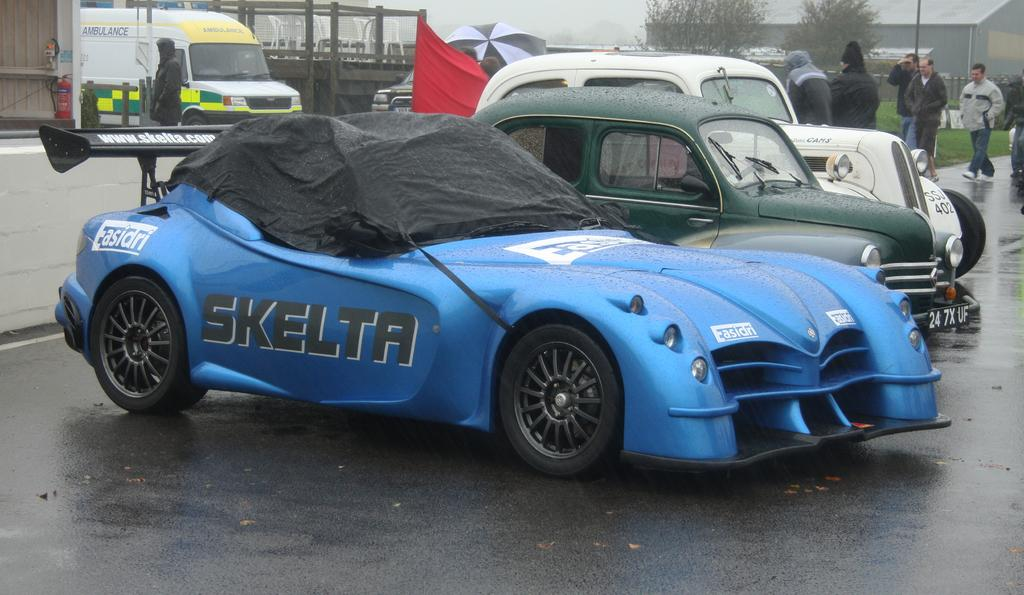What is happening on the road in the image? There are cars on a road in the image. What are the people in the image doing? People are walking in the image. What can be seen in the background of the image? There is a building, trees, and houses in the background of the image. What type of coat is the hill wearing in the image? There is no hill or coat present in the image. What kind of insurance policy is being discussed by the people walking in the image? There is no discussion of insurance in the image; people are simply walking. 